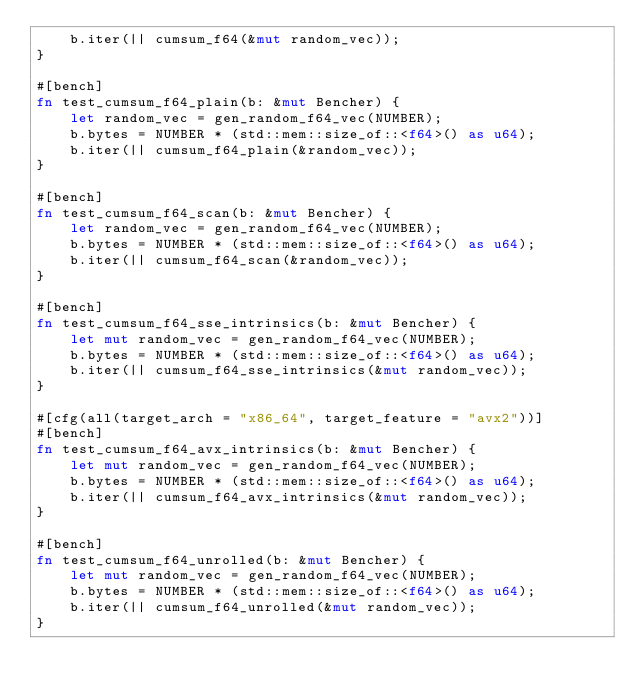<code> <loc_0><loc_0><loc_500><loc_500><_Rust_>    b.iter(|| cumsum_f64(&mut random_vec));
}

#[bench]
fn test_cumsum_f64_plain(b: &mut Bencher) {
    let random_vec = gen_random_f64_vec(NUMBER);
    b.bytes = NUMBER * (std::mem::size_of::<f64>() as u64);
    b.iter(|| cumsum_f64_plain(&random_vec));
}

#[bench]
fn test_cumsum_f64_scan(b: &mut Bencher) {
    let random_vec = gen_random_f64_vec(NUMBER);
    b.bytes = NUMBER * (std::mem::size_of::<f64>() as u64);
    b.iter(|| cumsum_f64_scan(&random_vec));
}

#[bench]
fn test_cumsum_f64_sse_intrinsics(b: &mut Bencher) {
    let mut random_vec = gen_random_f64_vec(NUMBER);
    b.bytes = NUMBER * (std::mem::size_of::<f64>() as u64);
    b.iter(|| cumsum_f64_sse_intrinsics(&mut random_vec));
}

#[cfg(all(target_arch = "x86_64", target_feature = "avx2"))]
#[bench]
fn test_cumsum_f64_avx_intrinsics(b: &mut Bencher) {
    let mut random_vec = gen_random_f64_vec(NUMBER);
    b.bytes = NUMBER * (std::mem::size_of::<f64>() as u64);
    b.iter(|| cumsum_f64_avx_intrinsics(&mut random_vec));
}

#[bench]
fn test_cumsum_f64_unrolled(b: &mut Bencher) {
    let mut random_vec = gen_random_f64_vec(NUMBER);
    b.bytes = NUMBER * (std::mem::size_of::<f64>() as u64);
    b.iter(|| cumsum_f64_unrolled(&mut random_vec));
}
</code> 